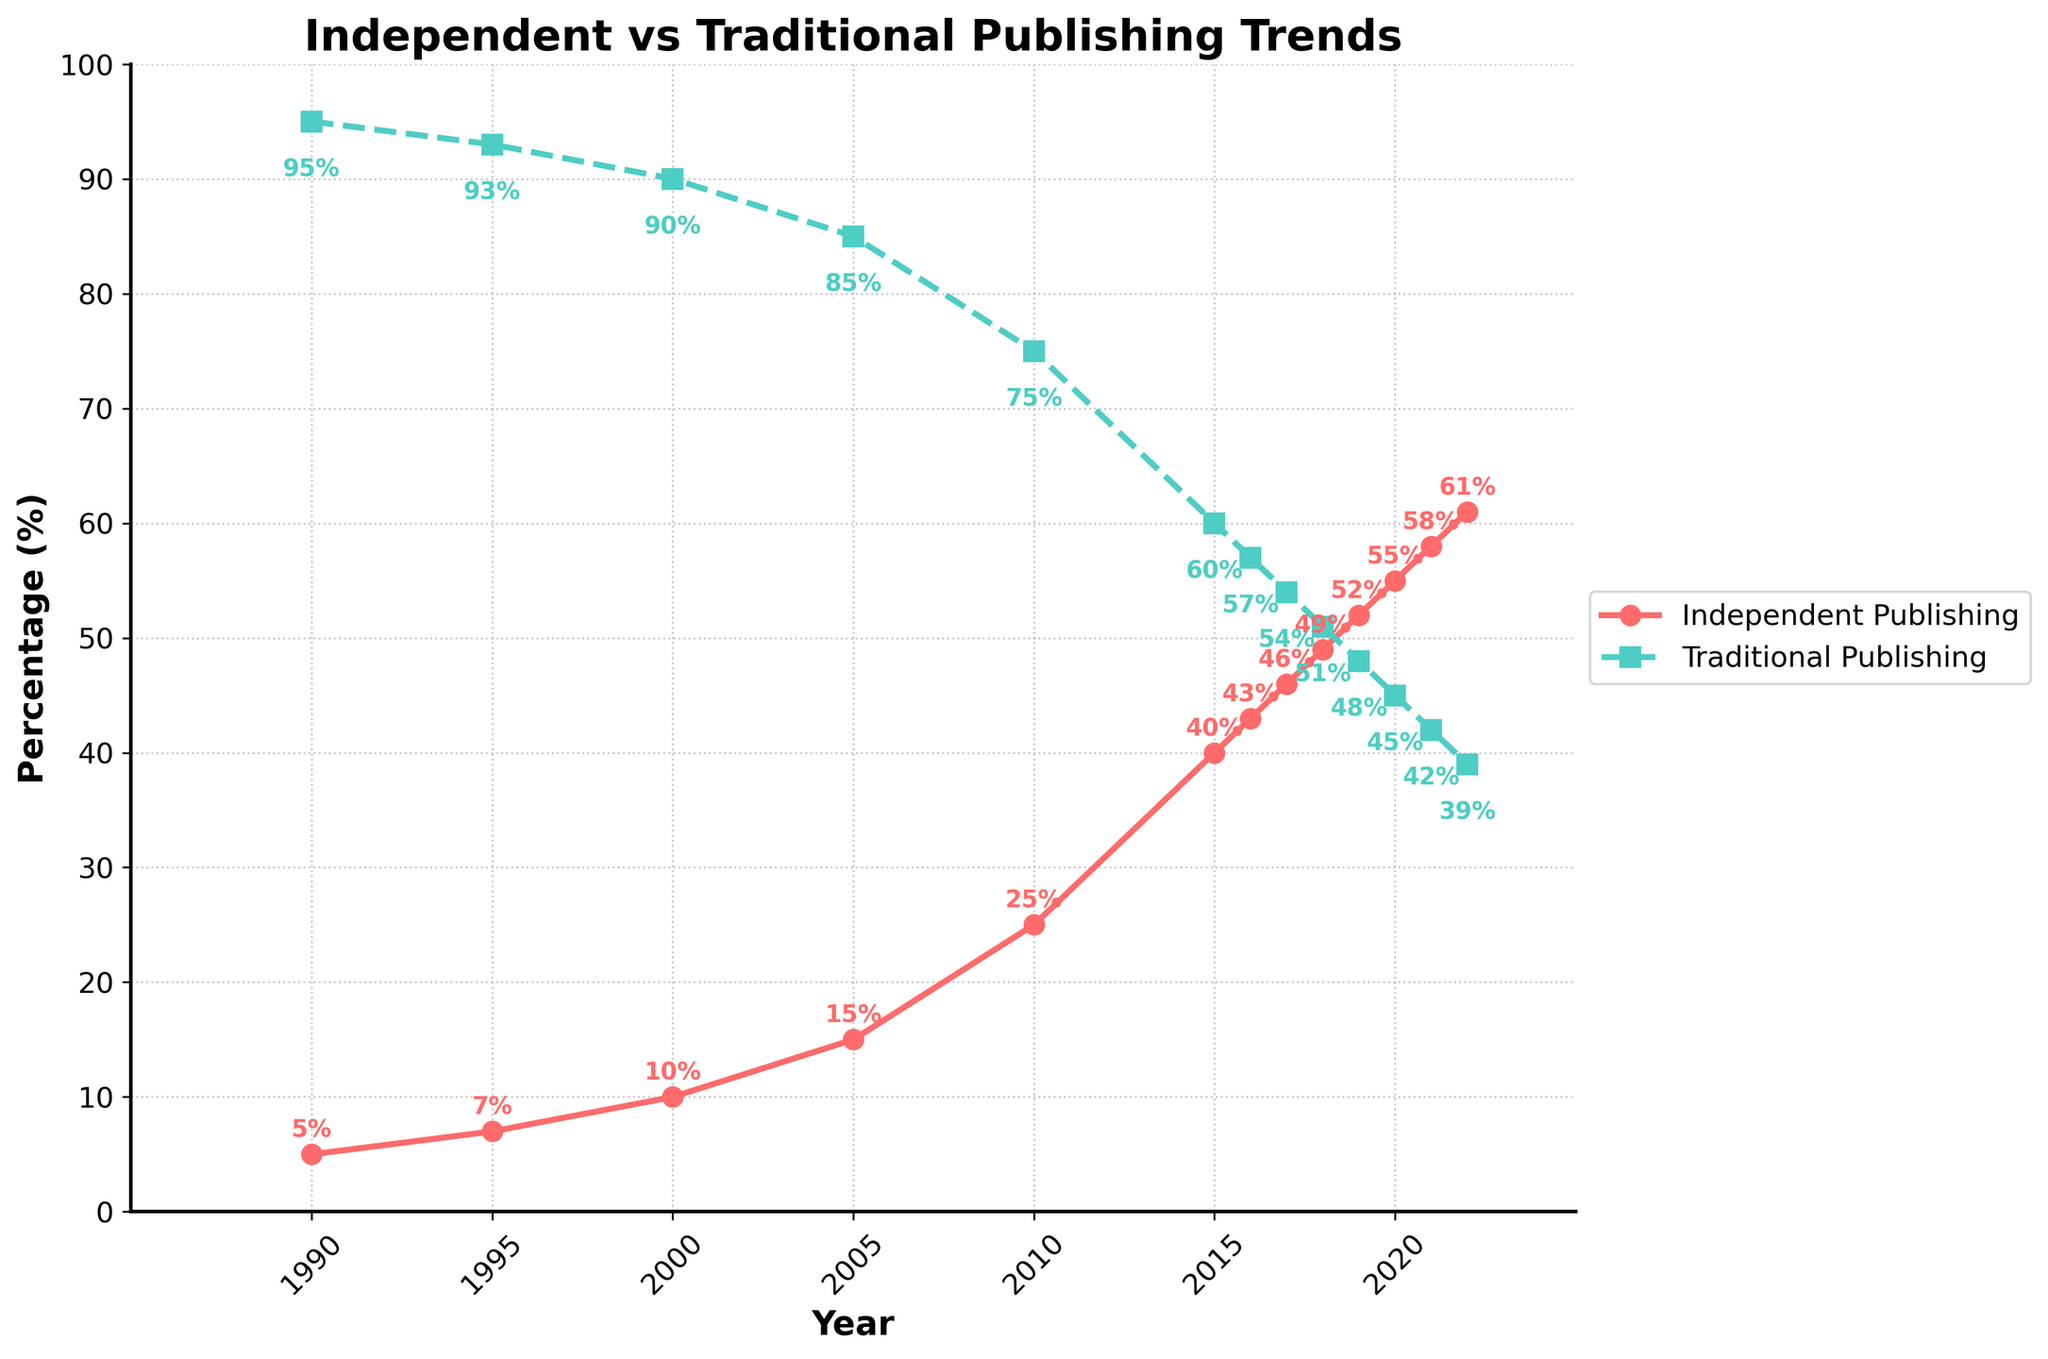What's the trend of independent publishing over the given time period? The line representing independent publishing shows a steady increase from 5% in 1990 to 61% in 2022, indicating a significant rise in independently published books over the years.
Answer: A steady increase How does the proportion of traditional publishing compare between 1990 and 2022? In 1990, traditional publishing was at 95%. By 2022, it had decreased to 39%. This shows a sharp decline in the proportion of traditionally published books.
Answer: Decreased from 95% to 39% What is the sum of the percentages for independent and traditional publishing in 2015? The percentage for independent publishing in 2015 is 40%, and for traditional publishing, it's 60%. Adding these up gives 40% + 60% = 100%.
Answer: 100% Which year shows an equal representation of independent and traditional publishing? According to the plot, the two lines intersect in 2018 where both percentages are equal at 49% for independent and 51% for traditional publishing.
Answer: 2018 Which year had the largest year-over-year increase in the percentage of independently published books? From the chart, the largest year-over-year increase for independent publishing occurred between 2010 and 2015, where the percentage went from 25% to 40%, an increase of 15%.
Answer: Between 2010 and 2015 What is the difference in the percentage of independent publishing between the years 2000 and 2022? The percentage of independent publishing in 2000 was 10%. By 2022, it increased to 61%. The difference is 61% - 10% = 51%.
Answer: 51% Compare the rate of change in independent publishing percentages between the periods 1990-2000 and 2010-2020. From 1990 to 2000, the independent publishing percentage increased from 5% to 10%, a total increase of 5%. From 2010 to 2020, it increased from 25% to 55%, a total increase of 30%. The rate of change from 2010-2020 is much higher than from 1990-2000.
Answer: 30% vs. 5% What visual difference can be noted between the lines representing independent and traditional publishing? The line representing independent publishing is marked with circles and is solid red, while the line representing traditional publishing is marked with squares and is dashed green.
Answer: Different markers and line styles Between which years did the percentage of independently published books surpass the halfway mark (50%)? According to the chart, the percentage of independently published books first surpassed the 50% mark between 2018 and 2019. In 2019, it reached 52%.
Answer: Between 2018 and 2019 At what percentage does traditional publishing start at in 1990? Traditional publishing starts at 95% in 1990 according to the chart.
Answer: 95% 